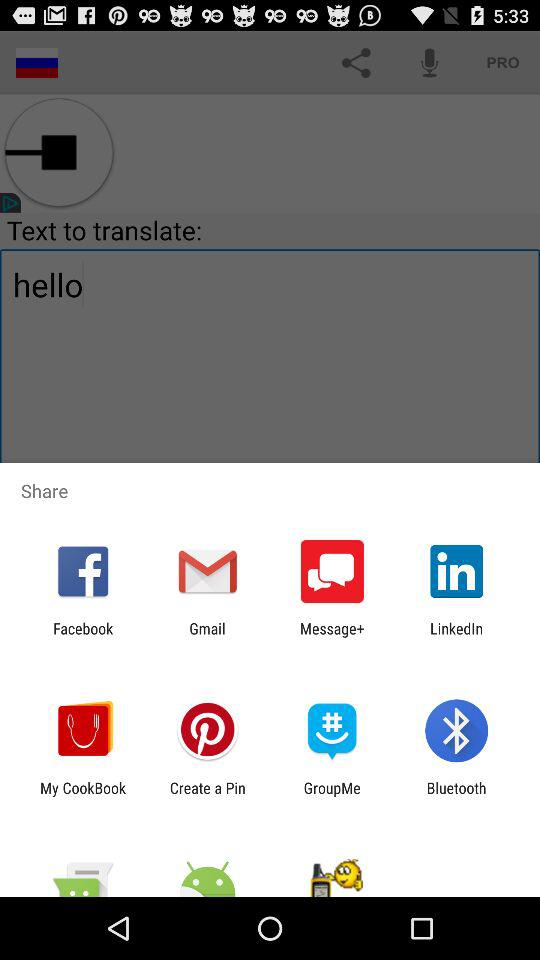How many more social media apps are there than messaging apps?
Answer the question using a single word or phrase. 2 